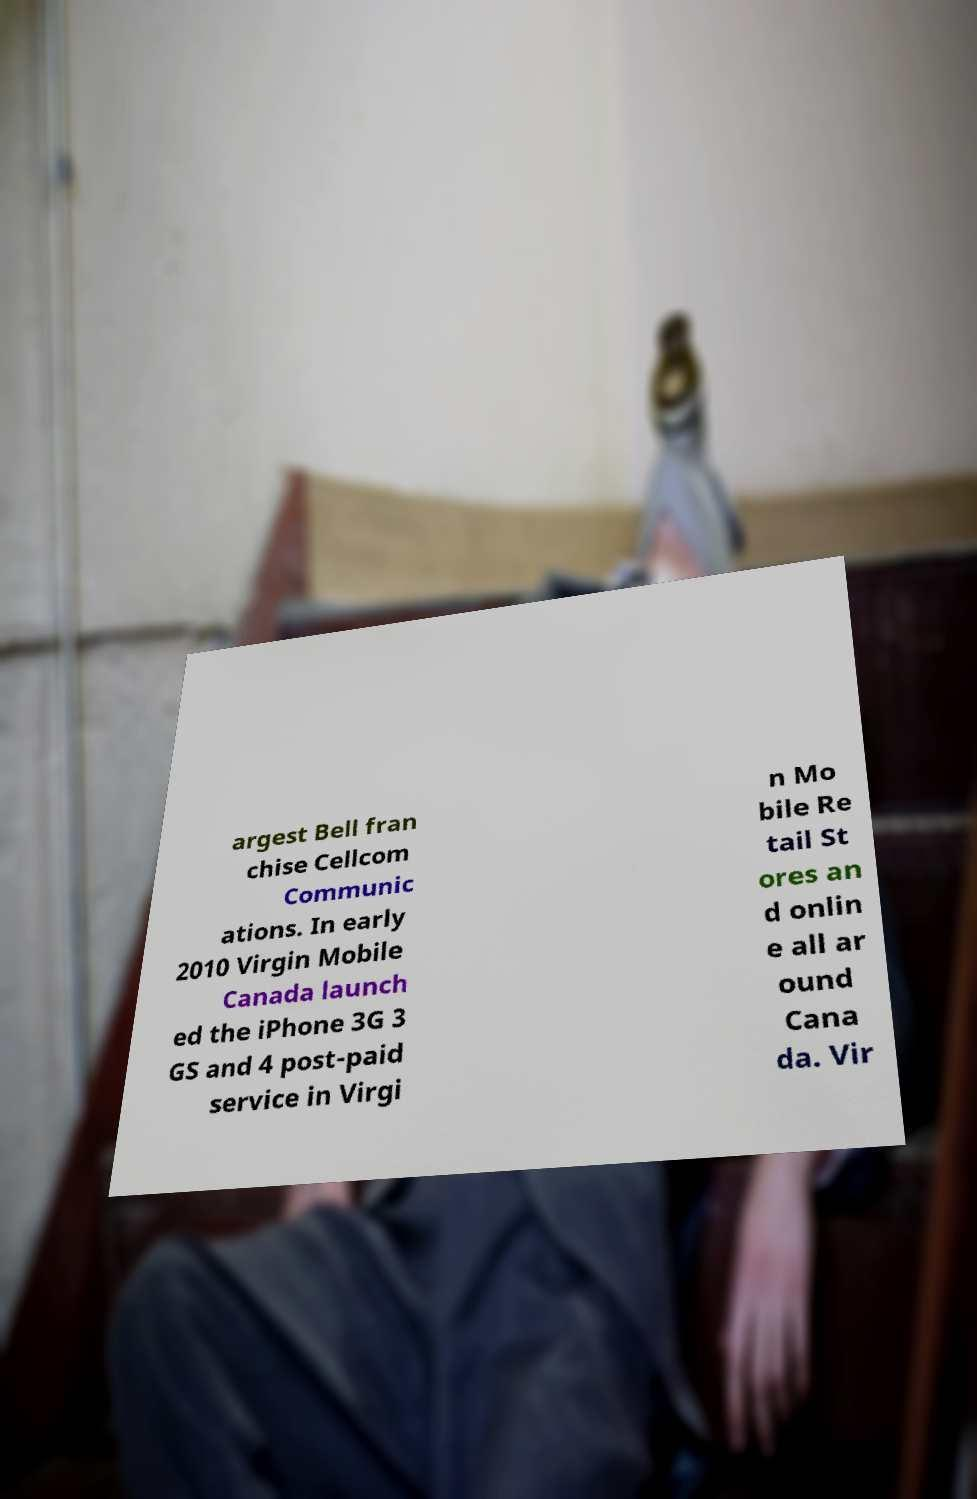Please read and relay the text visible in this image. What does it say? argest Bell fran chise Cellcom Communic ations. In early 2010 Virgin Mobile Canada launch ed the iPhone 3G 3 GS and 4 post-paid service in Virgi n Mo bile Re tail St ores an d onlin e all ar ound Cana da. Vir 